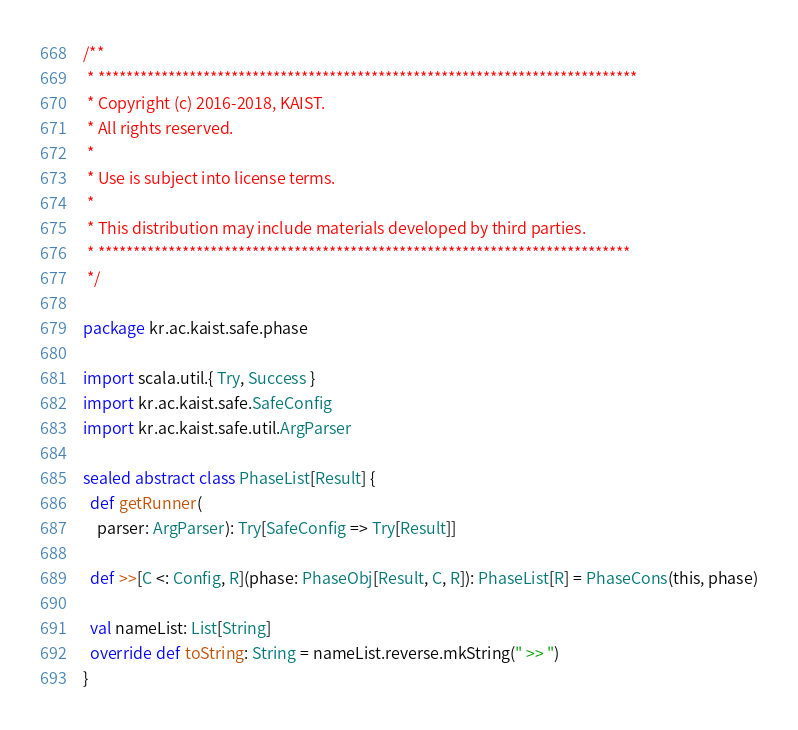<code> <loc_0><loc_0><loc_500><loc_500><_Scala_>/**
 * *****************************************************************************
 * Copyright (c) 2016-2018, KAIST.
 * All rights reserved.
 *
 * Use is subject into license terms.
 *
 * This distribution may include materials developed by third parties.
 * ****************************************************************************
 */

package kr.ac.kaist.safe.phase

import scala.util.{ Try, Success }
import kr.ac.kaist.safe.SafeConfig
import kr.ac.kaist.safe.util.ArgParser

sealed abstract class PhaseList[Result] {
  def getRunner(
    parser: ArgParser): Try[SafeConfig => Try[Result]]

  def >>[C <: Config, R](phase: PhaseObj[Result, C, R]): PhaseList[R] = PhaseCons(this, phase)

  val nameList: List[String]
  override def toString: String = nameList.reverse.mkString(" >> ")
}
</code> 